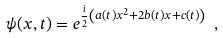<formula> <loc_0><loc_0><loc_500><loc_500>\psi ( x , t ) = e ^ { \frac { i } { 2 } \left ( a ( t ) x ^ { 2 } + 2 b ( t ) x + c ( t ) \right ) } \ ,</formula> 